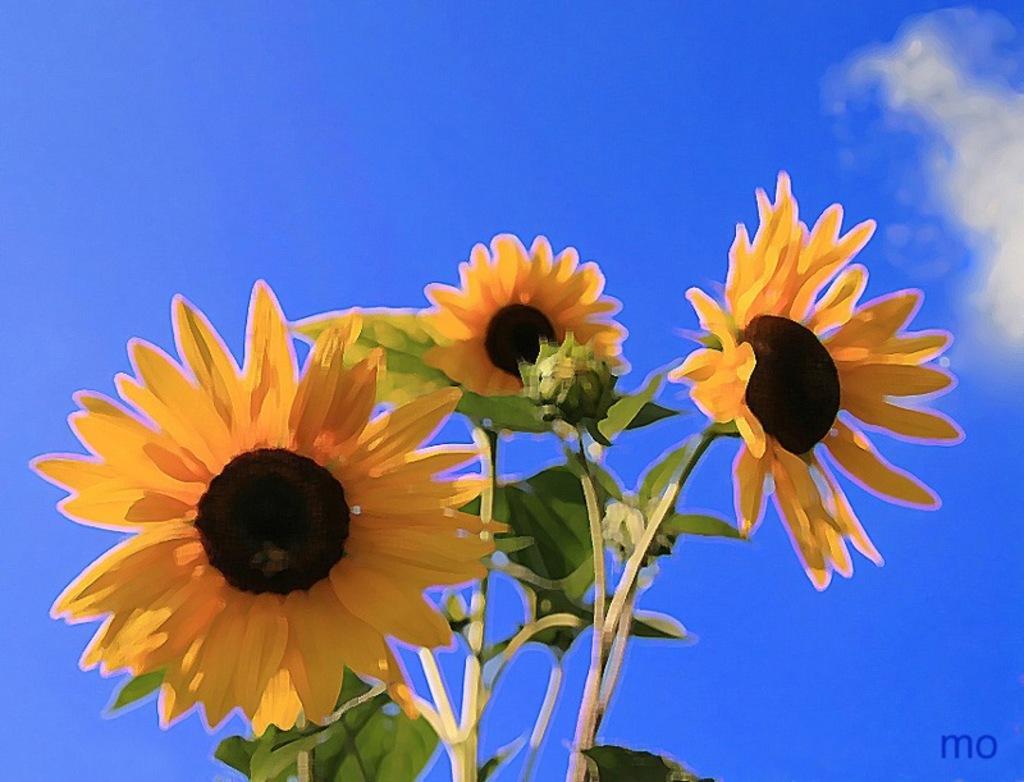Can you describe this image briefly? It is looking like a painting of three sunflowers to the stems. Behind the flowers there is a sky and on the image there is a watermark. 